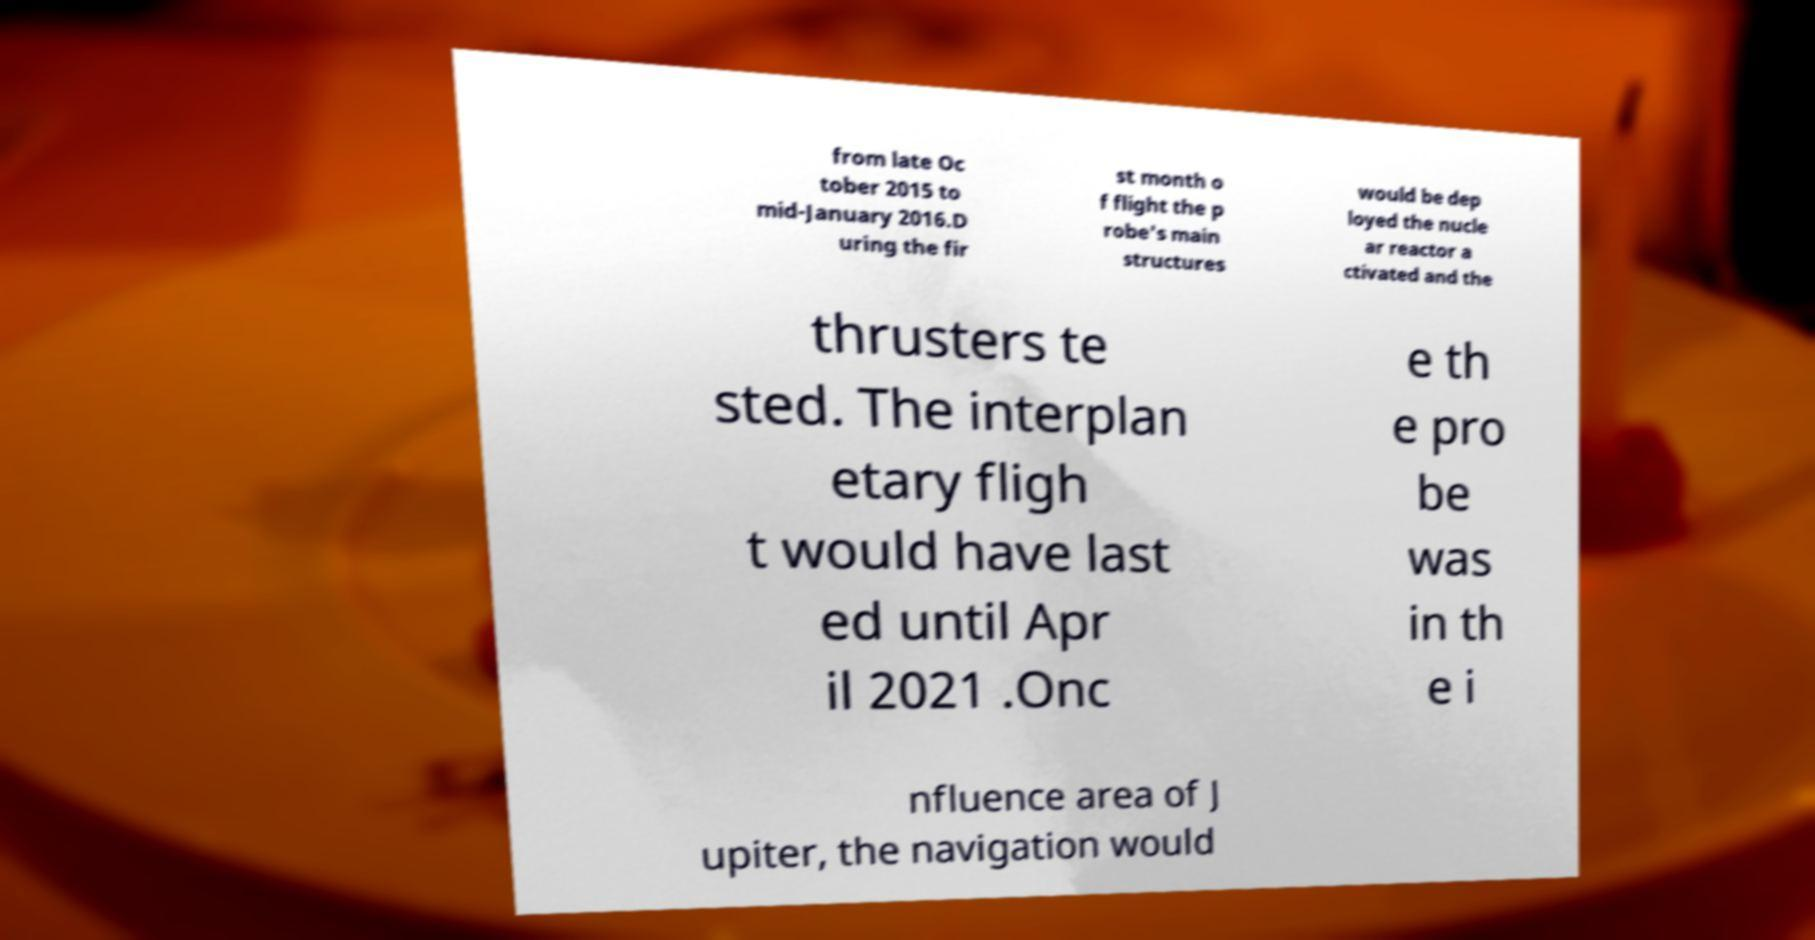For documentation purposes, I need the text within this image transcribed. Could you provide that? from late Oc tober 2015 to mid-January 2016.D uring the fir st month o f flight the p robe's main structures would be dep loyed the nucle ar reactor a ctivated and the thrusters te sted. The interplan etary fligh t would have last ed until Apr il 2021 .Onc e th e pro be was in th e i nfluence area of J upiter, the navigation would 